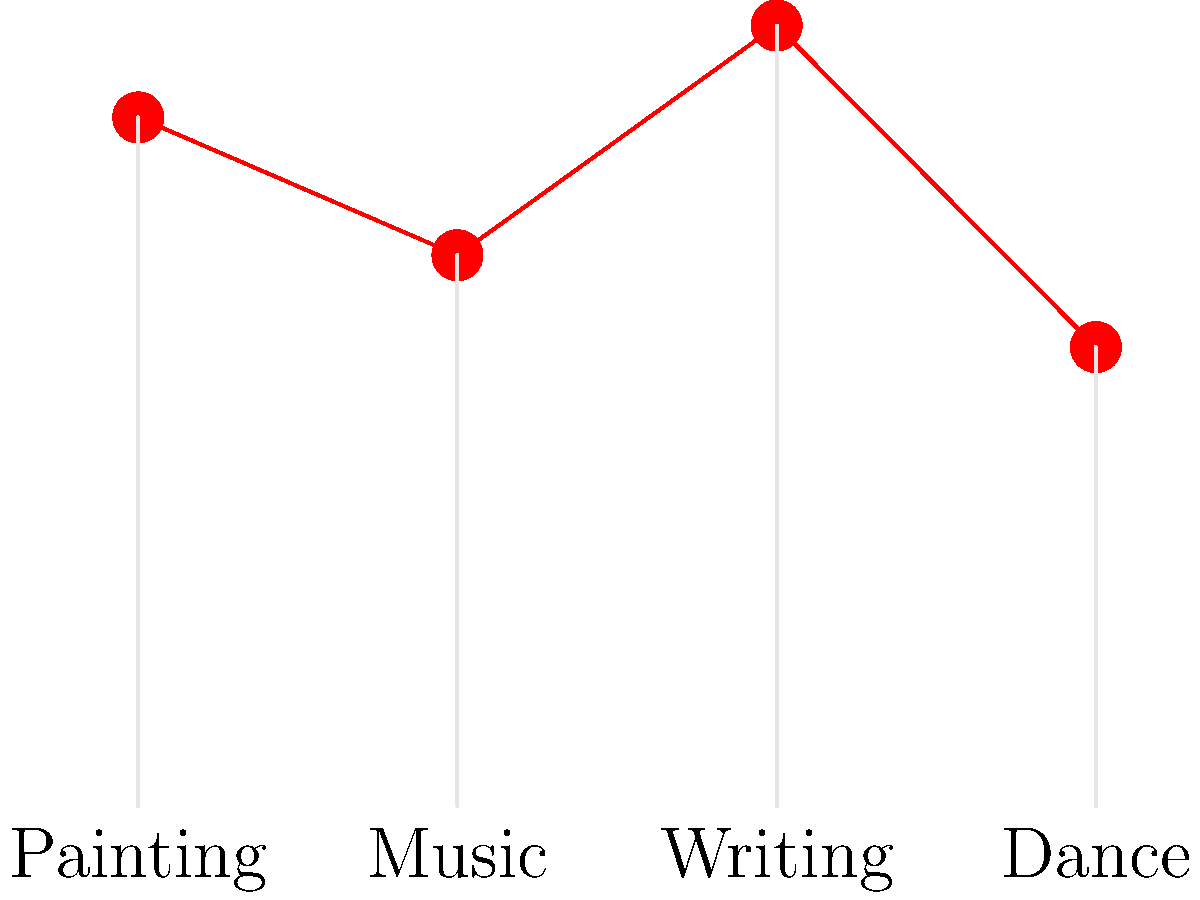Based on the bar graph showing creativity scores across different art forms, which art form demonstrates the highest level of creativity according to the study? How might this finding influence interdisciplinary research projects between arts and sciences? To answer this question, we need to analyze the bar graph and interpret its data:

1. The graph shows creativity scores for four art forms: Painting, Music, Writing, and Dance.
2. The y-axis represents the creativity score, while the x-axis shows the different art forms.
3. We need to compare the heights of the bars to determine which art form has the highest creativity score.

Analyzing the bars:
- Painting: approximately 75
- Music: approximately 60
- Writing: approximately 85
- Dance: approximately 50

Writing has the tallest bar, indicating the highest creativity score of about 85.

Regarding the influence on interdisciplinary research:

1. This finding suggests that writing might be a particularly fruitful area for collaboration between arts and sciences.
2. It could lead to research projects exploring the cognitive processes behind creative writing and how they relate to scientific thinking.
3. The result might inspire investigations into why writing scored higher in creativity compared to other art forms, potentially uncovering unique aspects of linguistic and narrative creativity.
4. It could encourage the development of writing-based methodologies for enhancing creativity in scientific research and problem-solving.
5. The varying scores across art forms might prompt studies on how different creative processes could be integrated into scientific work to boost innovation and out-of-the-box thinking.
Answer: Writing; potential for writing-based creativity studies and integration of narrative techniques in scientific research. 